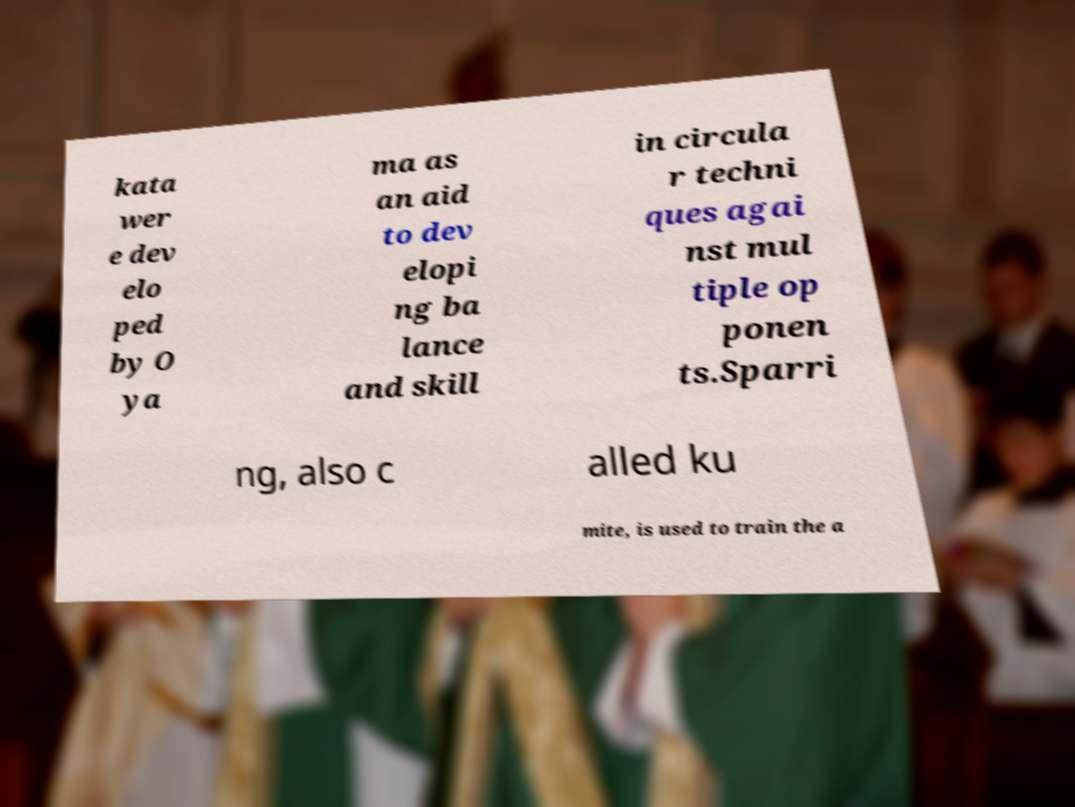Could you extract and type out the text from this image? kata wer e dev elo ped by O ya ma as an aid to dev elopi ng ba lance and skill in circula r techni ques agai nst mul tiple op ponen ts.Sparri ng, also c alled ku mite, is used to train the a 